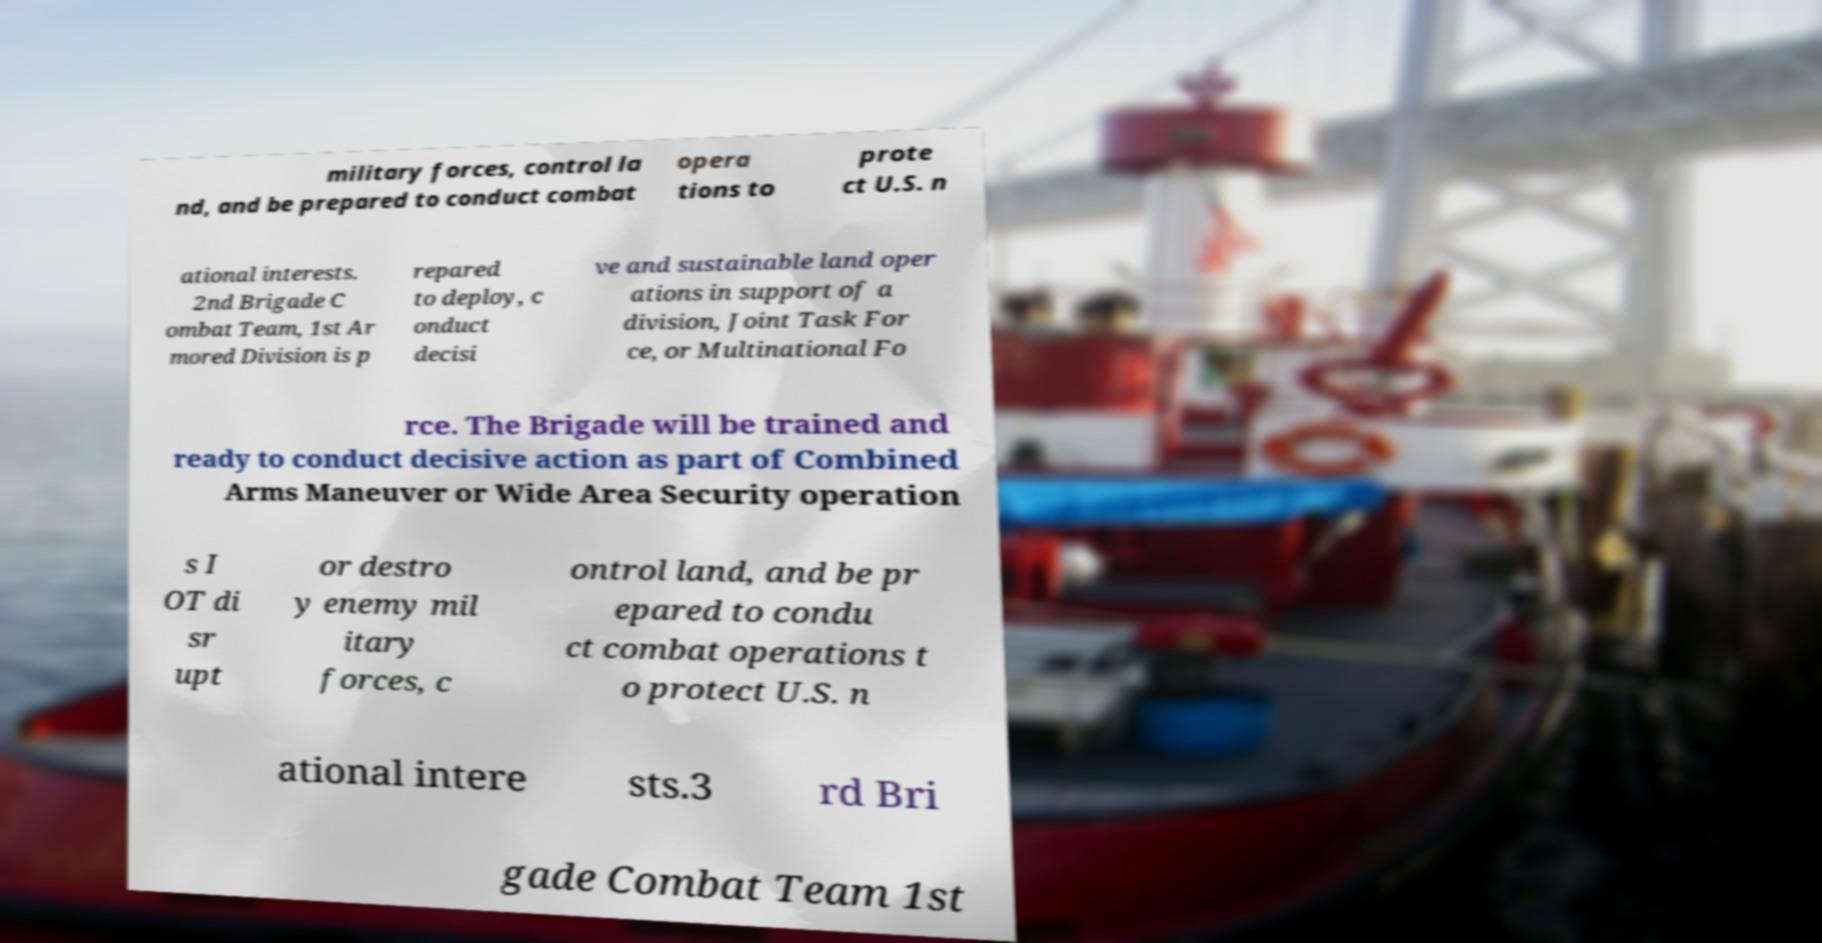There's text embedded in this image that I need extracted. Can you transcribe it verbatim? military forces, control la nd, and be prepared to conduct combat opera tions to prote ct U.S. n ational interests. 2nd Brigade C ombat Team, 1st Ar mored Division is p repared to deploy, c onduct decisi ve and sustainable land oper ations in support of a division, Joint Task For ce, or Multinational Fo rce. The Brigade will be trained and ready to conduct decisive action as part of Combined Arms Maneuver or Wide Area Security operation s I OT di sr upt or destro y enemy mil itary forces, c ontrol land, and be pr epared to condu ct combat operations t o protect U.S. n ational intere sts.3 rd Bri gade Combat Team 1st 